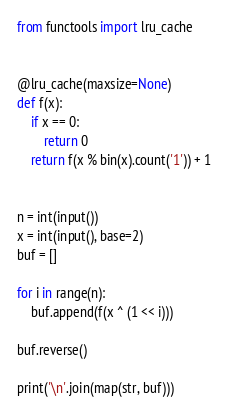Convert code to text. <code><loc_0><loc_0><loc_500><loc_500><_Python_>from functools import lru_cache


@lru_cache(maxsize=None)
def f(x):
    if x == 0:
        return 0
    return f(x % bin(x).count('1')) + 1


n = int(input())
x = int(input(), base=2)
buf = []

for i in range(n):
    buf.append(f(x ^ (1 << i)))

buf.reverse()

print('\n'.join(map(str, buf)))
</code> 